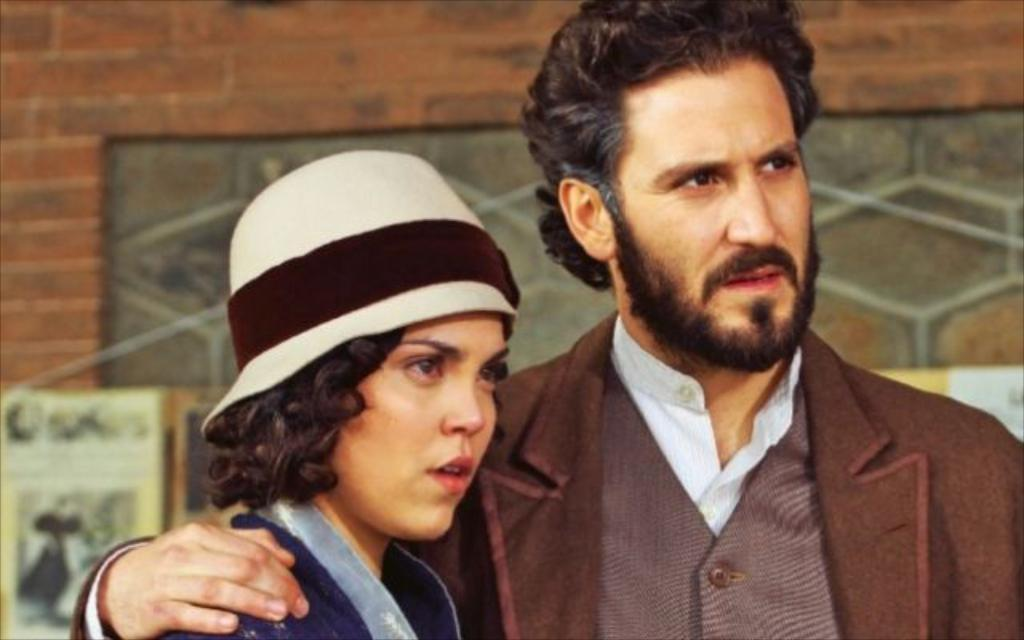How many people are in the image? There are two persons in the image. Where are the two persons located in relation to the image? The two persons are in front. What is behind the two persons in the image? There is a wall behind the two persons. What type of dinosaurs can be seen walking on the sidewalk in the image? There are no dinosaurs or sidewalks present in the image. 